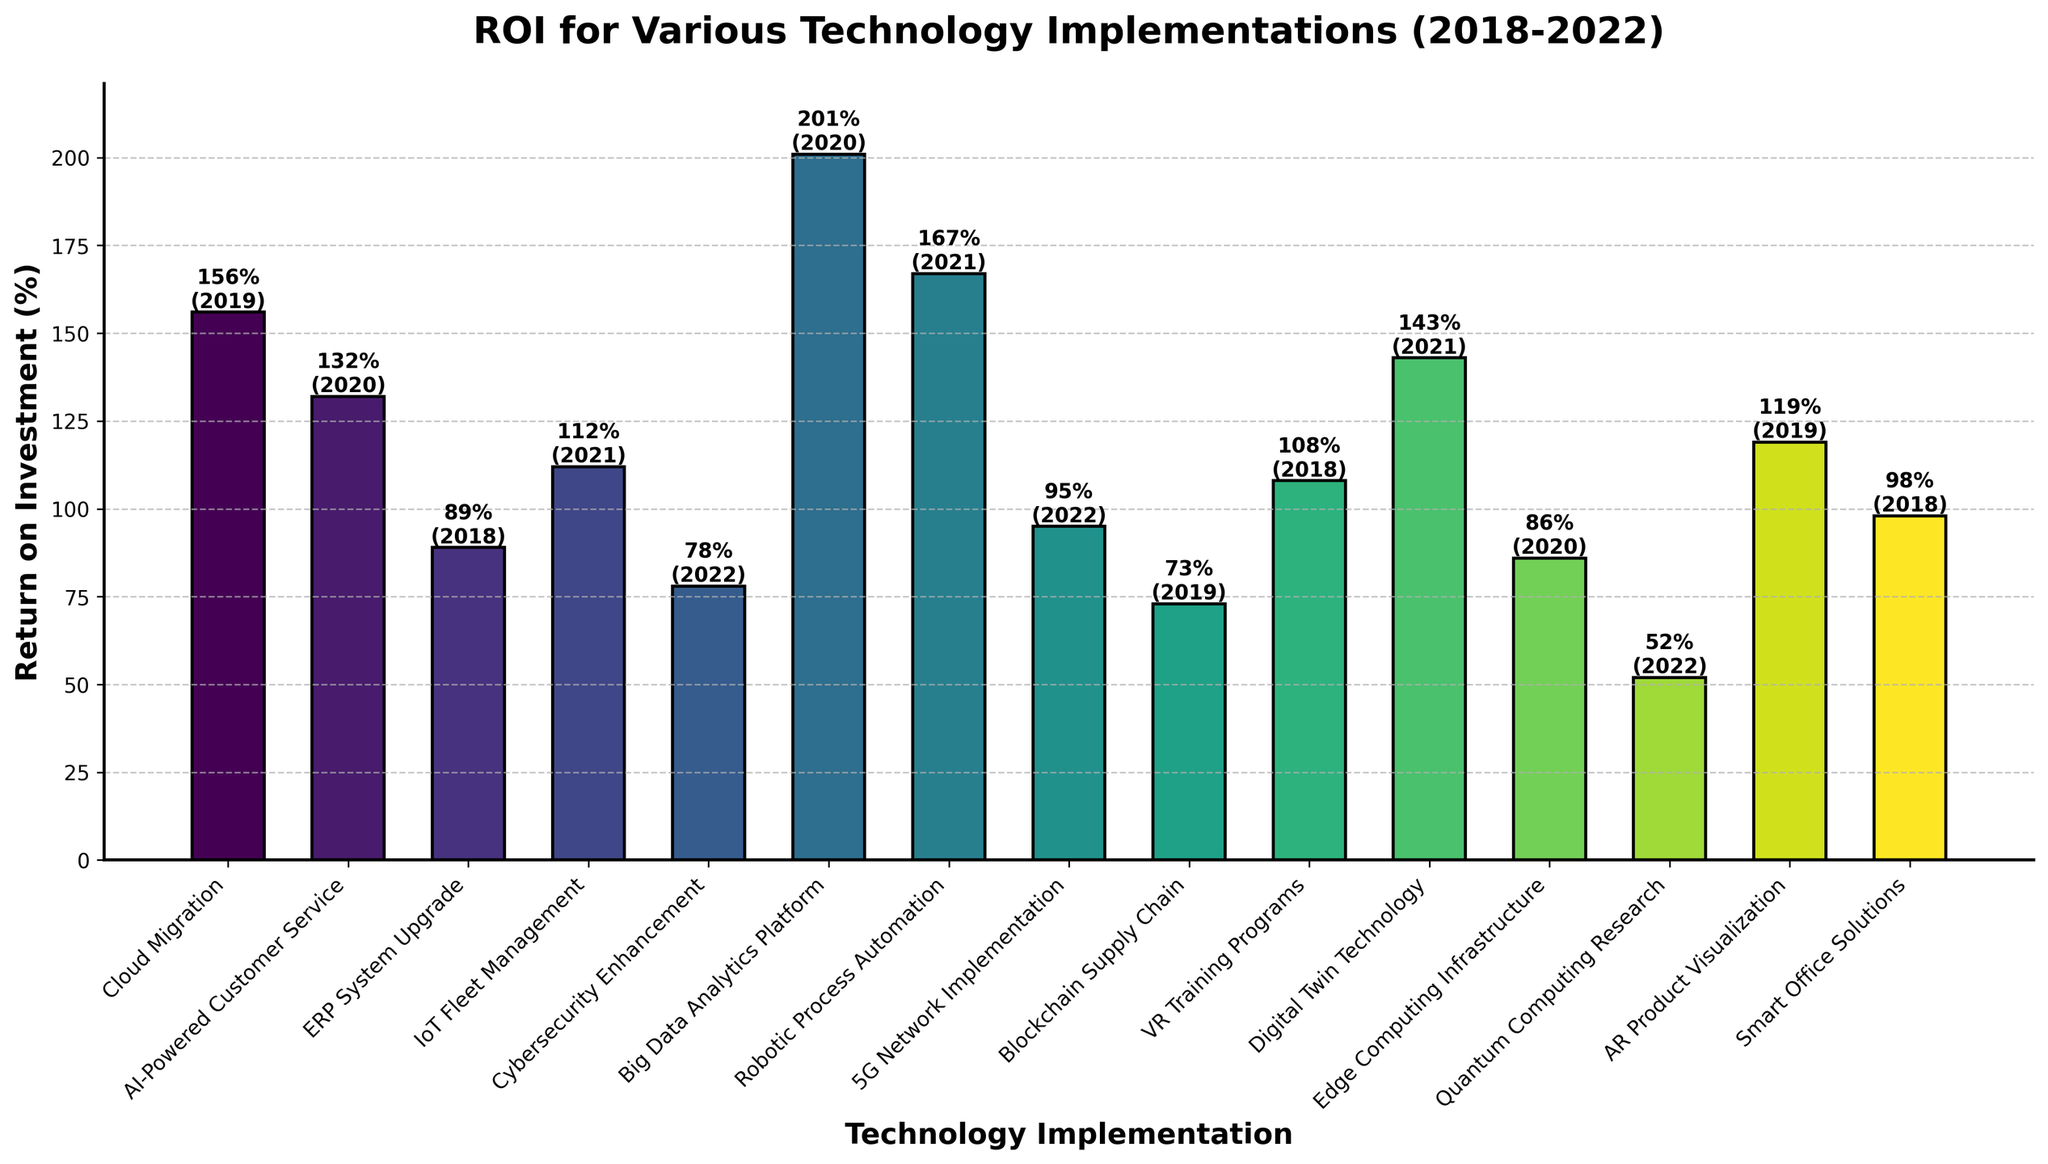Which technology implementation had the highest ROI between 2018 and 2022? By looking at the heights of the bars, it is clear that the 'Big Data Analytics Platform' bar is the tallest, indicating the highest ROI at 201%.
Answer: Big Data Analytics Platform How does the ROI of 'Blockchain Supply Chain' compare to 'Cloud Migration'? The bar for 'Blockchain Supply Chain' is shorter than that for 'Cloud Migration'. 'Blockchain Supply Chain' has an ROI of 73% while 'Cloud Migration' has 156%.
Answer: Blockchain Supply Chain has lower ROI Which technology implementations have an ROI greater than 150%? By observing the heights of the bars, the technologies with an ROI greater than 150% are 'Cloud Migration' (156%), 'Big Data Analytics Platform' (201%), and 'Robotic Process Automation' (167%).
Answer: Cloud Migration, Big Data Analytics Platform, Robotic Process Automation What is the average ROI of the technologies implemented in 2022? The technologies from 2022 are 'Cybersecurity Enhancement' (78%), '5G Network Implementation' (95%), and 'Quantum Computing Research' (52%). Summing these up gives 78 + 95 + 52 = 225 and the average ROI is 225/3 ≈ 75%.
Answer: 75% How much higher is the ROI of 'Robotic Process Automation' than 'ERP System Upgrade'? 'Robotic Process Automation' has an ROI of 167% and 'ERP System Upgrade' has an ROI of 89%. The difference is 167 - 89 = 78%.
Answer: 78% higher Which technology implementation in 2019 had the lowest ROI? From the data, the 2019 technologies are 'Cloud Migration', 'Blockchain Supply Chain', and 'AR Product Visualization' with ROIs of 156%, 73%, and 119% respectively. The lowest is 'Blockchain Supply Chain' at 73%.
Answer: Blockchain Supply Chain What is the ROI difference between 'IoT Fleet Management' and 'Digital Twin Technology'? 'IoT Fleet Management' has an ROI of 112% and 'Digital Twin Technology' has 143%. The difference is 143 - 112 = 31%.
Answer: 31% Which bar is visually the shortest in the chart, and what is its ROI? The 'Quantum Computing Research' bar is the shortest, indicating the lowest ROI of 52%.
Answer: Quantum Computing Research What is the combined ROI of all 2020 technology implementations? The technologies from 2020 are 'AI-Powered Customer Service' (132%), 'Big Data Analytics Platform' (201%), and 'Edge Computing Infrastructure' (86%). Summing these up gives 132 + 201 + 86 = 419.
Answer: 419% 